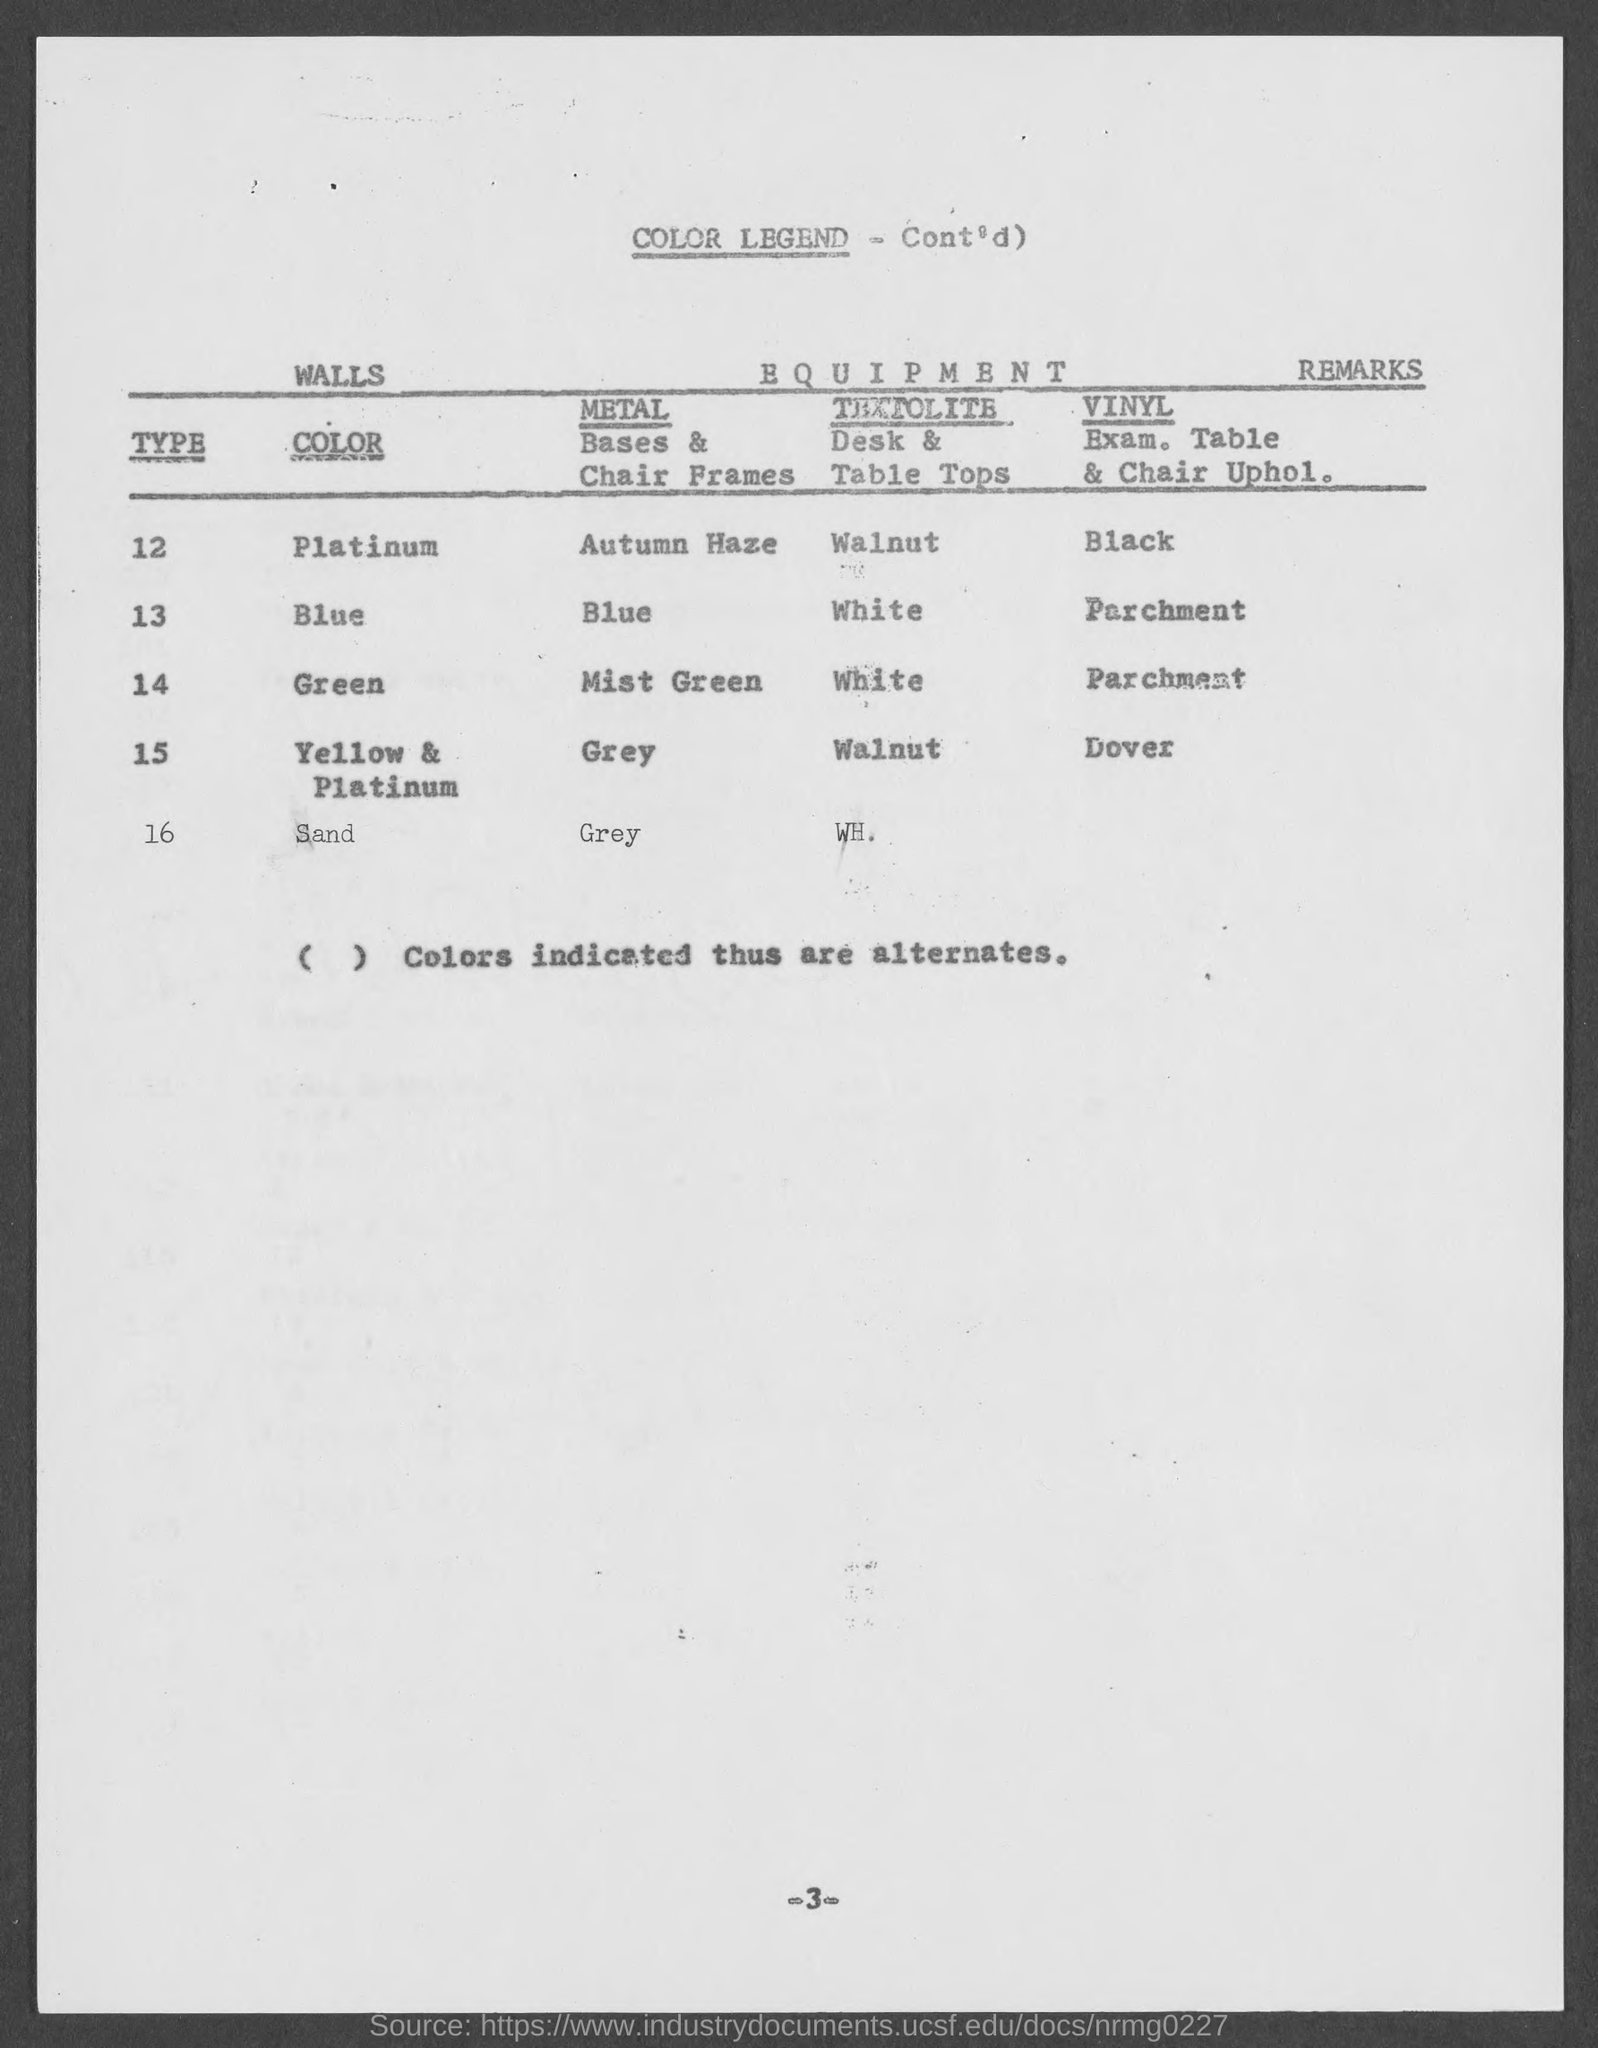Give some essential details in this illustration. Type 14 is indicated by the color green. Type 12 indicates Platinum. 